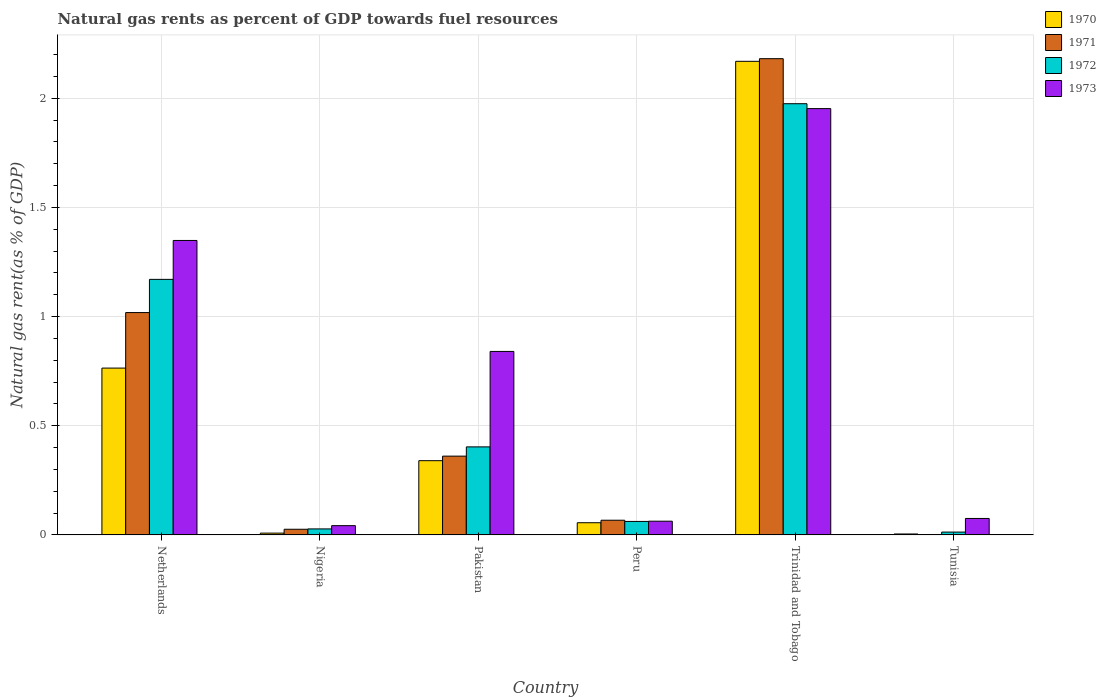How many different coloured bars are there?
Provide a short and direct response. 4. How many groups of bars are there?
Offer a very short reply. 6. What is the label of the 2nd group of bars from the left?
Offer a very short reply. Nigeria. What is the natural gas rent in 1970 in Nigeria?
Make the answer very short. 0.01. Across all countries, what is the maximum natural gas rent in 1972?
Your answer should be very brief. 1.98. Across all countries, what is the minimum natural gas rent in 1970?
Your answer should be compact. 0. In which country was the natural gas rent in 1972 maximum?
Keep it short and to the point. Trinidad and Tobago. In which country was the natural gas rent in 1972 minimum?
Ensure brevity in your answer.  Tunisia. What is the total natural gas rent in 1971 in the graph?
Your answer should be compact. 3.65. What is the difference between the natural gas rent in 1972 in Netherlands and that in Trinidad and Tobago?
Keep it short and to the point. -0.8. What is the difference between the natural gas rent in 1970 in Netherlands and the natural gas rent in 1972 in Tunisia?
Provide a short and direct response. 0.75. What is the average natural gas rent in 1972 per country?
Offer a terse response. 0.61. What is the difference between the natural gas rent of/in 1972 and natural gas rent of/in 1973 in Trinidad and Tobago?
Offer a terse response. 0.02. In how many countries, is the natural gas rent in 1970 greater than 1.6 %?
Give a very brief answer. 1. What is the ratio of the natural gas rent in 1971 in Pakistan to that in Trinidad and Tobago?
Your answer should be compact. 0.17. Is the natural gas rent in 1971 in Trinidad and Tobago less than that in Tunisia?
Provide a short and direct response. No. Is the difference between the natural gas rent in 1972 in Netherlands and Pakistan greater than the difference between the natural gas rent in 1973 in Netherlands and Pakistan?
Your answer should be compact. Yes. What is the difference between the highest and the second highest natural gas rent in 1970?
Provide a short and direct response. 0.42. What is the difference between the highest and the lowest natural gas rent in 1972?
Make the answer very short. 1.96. What does the 4th bar from the right in Trinidad and Tobago represents?
Ensure brevity in your answer.  1970. How many countries are there in the graph?
Ensure brevity in your answer.  6. Are the values on the major ticks of Y-axis written in scientific E-notation?
Make the answer very short. No. Where does the legend appear in the graph?
Ensure brevity in your answer.  Top right. How many legend labels are there?
Make the answer very short. 4. How are the legend labels stacked?
Ensure brevity in your answer.  Vertical. What is the title of the graph?
Keep it short and to the point. Natural gas rents as percent of GDP towards fuel resources. Does "2001" appear as one of the legend labels in the graph?
Give a very brief answer. No. What is the label or title of the Y-axis?
Provide a short and direct response. Natural gas rent(as % of GDP). What is the Natural gas rent(as % of GDP) of 1970 in Netherlands?
Give a very brief answer. 0.76. What is the Natural gas rent(as % of GDP) of 1971 in Netherlands?
Provide a short and direct response. 1.02. What is the Natural gas rent(as % of GDP) of 1972 in Netherlands?
Offer a terse response. 1.17. What is the Natural gas rent(as % of GDP) of 1973 in Netherlands?
Your answer should be compact. 1.35. What is the Natural gas rent(as % of GDP) in 1970 in Nigeria?
Your answer should be very brief. 0.01. What is the Natural gas rent(as % of GDP) of 1971 in Nigeria?
Provide a short and direct response. 0.03. What is the Natural gas rent(as % of GDP) of 1972 in Nigeria?
Your response must be concise. 0.03. What is the Natural gas rent(as % of GDP) in 1973 in Nigeria?
Keep it short and to the point. 0.04. What is the Natural gas rent(as % of GDP) of 1970 in Pakistan?
Your answer should be compact. 0.34. What is the Natural gas rent(as % of GDP) in 1971 in Pakistan?
Make the answer very short. 0.36. What is the Natural gas rent(as % of GDP) of 1972 in Pakistan?
Your answer should be compact. 0.4. What is the Natural gas rent(as % of GDP) of 1973 in Pakistan?
Ensure brevity in your answer.  0.84. What is the Natural gas rent(as % of GDP) in 1970 in Peru?
Your response must be concise. 0.06. What is the Natural gas rent(as % of GDP) in 1971 in Peru?
Give a very brief answer. 0.07. What is the Natural gas rent(as % of GDP) in 1972 in Peru?
Offer a very short reply. 0.06. What is the Natural gas rent(as % of GDP) in 1973 in Peru?
Your response must be concise. 0.06. What is the Natural gas rent(as % of GDP) of 1970 in Trinidad and Tobago?
Your answer should be compact. 2.17. What is the Natural gas rent(as % of GDP) in 1971 in Trinidad and Tobago?
Your response must be concise. 2.18. What is the Natural gas rent(as % of GDP) in 1972 in Trinidad and Tobago?
Provide a short and direct response. 1.98. What is the Natural gas rent(as % of GDP) in 1973 in Trinidad and Tobago?
Your answer should be compact. 1.95. What is the Natural gas rent(as % of GDP) in 1970 in Tunisia?
Keep it short and to the point. 0. What is the Natural gas rent(as % of GDP) in 1971 in Tunisia?
Your answer should be very brief. 0. What is the Natural gas rent(as % of GDP) of 1972 in Tunisia?
Your answer should be very brief. 0.01. What is the Natural gas rent(as % of GDP) of 1973 in Tunisia?
Provide a short and direct response. 0.08. Across all countries, what is the maximum Natural gas rent(as % of GDP) in 1970?
Give a very brief answer. 2.17. Across all countries, what is the maximum Natural gas rent(as % of GDP) in 1971?
Make the answer very short. 2.18. Across all countries, what is the maximum Natural gas rent(as % of GDP) of 1972?
Provide a short and direct response. 1.98. Across all countries, what is the maximum Natural gas rent(as % of GDP) of 1973?
Your answer should be very brief. 1.95. Across all countries, what is the minimum Natural gas rent(as % of GDP) of 1970?
Give a very brief answer. 0. Across all countries, what is the minimum Natural gas rent(as % of GDP) of 1971?
Offer a terse response. 0. Across all countries, what is the minimum Natural gas rent(as % of GDP) of 1972?
Make the answer very short. 0.01. Across all countries, what is the minimum Natural gas rent(as % of GDP) in 1973?
Give a very brief answer. 0.04. What is the total Natural gas rent(as % of GDP) of 1970 in the graph?
Offer a terse response. 3.34. What is the total Natural gas rent(as % of GDP) of 1971 in the graph?
Provide a succinct answer. 3.65. What is the total Natural gas rent(as % of GDP) in 1972 in the graph?
Keep it short and to the point. 3.65. What is the total Natural gas rent(as % of GDP) in 1973 in the graph?
Give a very brief answer. 4.32. What is the difference between the Natural gas rent(as % of GDP) of 1970 in Netherlands and that in Nigeria?
Make the answer very short. 0.76. What is the difference between the Natural gas rent(as % of GDP) of 1972 in Netherlands and that in Nigeria?
Provide a short and direct response. 1.14. What is the difference between the Natural gas rent(as % of GDP) of 1973 in Netherlands and that in Nigeria?
Give a very brief answer. 1.31. What is the difference between the Natural gas rent(as % of GDP) of 1970 in Netherlands and that in Pakistan?
Your response must be concise. 0.42. What is the difference between the Natural gas rent(as % of GDP) in 1971 in Netherlands and that in Pakistan?
Keep it short and to the point. 0.66. What is the difference between the Natural gas rent(as % of GDP) in 1972 in Netherlands and that in Pakistan?
Keep it short and to the point. 0.77. What is the difference between the Natural gas rent(as % of GDP) in 1973 in Netherlands and that in Pakistan?
Make the answer very short. 0.51. What is the difference between the Natural gas rent(as % of GDP) of 1970 in Netherlands and that in Peru?
Provide a short and direct response. 0.71. What is the difference between the Natural gas rent(as % of GDP) in 1971 in Netherlands and that in Peru?
Your answer should be compact. 0.95. What is the difference between the Natural gas rent(as % of GDP) of 1972 in Netherlands and that in Peru?
Your answer should be compact. 1.11. What is the difference between the Natural gas rent(as % of GDP) of 1973 in Netherlands and that in Peru?
Make the answer very short. 1.29. What is the difference between the Natural gas rent(as % of GDP) of 1970 in Netherlands and that in Trinidad and Tobago?
Your response must be concise. -1.41. What is the difference between the Natural gas rent(as % of GDP) in 1971 in Netherlands and that in Trinidad and Tobago?
Your answer should be very brief. -1.16. What is the difference between the Natural gas rent(as % of GDP) of 1972 in Netherlands and that in Trinidad and Tobago?
Offer a very short reply. -0.8. What is the difference between the Natural gas rent(as % of GDP) in 1973 in Netherlands and that in Trinidad and Tobago?
Give a very brief answer. -0.6. What is the difference between the Natural gas rent(as % of GDP) in 1970 in Netherlands and that in Tunisia?
Keep it short and to the point. 0.76. What is the difference between the Natural gas rent(as % of GDP) of 1971 in Netherlands and that in Tunisia?
Make the answer very short. 1.02. What is the difference between the Natural gas rent(as % of GDP) of 1972 in Netherlands and that in Tunisia?
Give a very brief answer. 1.16. What is the difference between the Natural gas rent(as % of GDP) in 1973 in Netherlands and that in Tunisia?
Give a very brief answer. 1.27. What is the difference between the Natural gas rent(as % of GDP) in 1970 in Nigeria and that in Pakistan?
Keep it short and to the point. -0.33. What is the difference between the Natural gas rent(as % of GDP) in 1971 in Nigeria and that in Pakistan?
Give a very brief answer. -0.34. What is the difference between the Natural gas rent(as % of GDP) of 1972 in Nigeria and that in Pakistan?
Keep it short and to the point. -0.38. What is the difference between the Natural gas rent(as % of GDP) in 1973 in Nigeria and that in Pakistan?
Provide a short and direct response. -0.8. What is the difference between the Natural gas rent(as % of GDP) in 1970 in Nigeria and that in Peru?
Make the answer very short. -0.05. What is the difference between the Natural gas rent(as % of GDP) in 1971 in Nigeria and that in Peru?
Offer a terse response. -0.04. What is the difference between the Natural gas rent(as % of GDP) in 1972 in Nigeria and that in Peru?
Make the answer very short. -0.03. What is the difference between the Natural gas rent(as % of GDP) of 1973 in Nigeria and that in Peru?
Give a very brief answer. -0.02. What is the difference between the Natural gas rent(as % of GDP) in 1970 in Nigeria and that in Trinidad and Tobago?
Provide a short and direct response. -2.16. What is the difference between the Natural gas rent(as % of GDP) of 1971 in Nigeria and that in Trinidad and Tobago?
Keep it short and to the point. -2.16. What is the difference between the Natural gas rent(as % of GDP) in 1972 in Nigeria and that in Trinidad and Tobago?
Offer a terse response. -1.95. What is the difference between the Natural gas rent(as % of GDP) in 1973 in Nigeria and that in Trinidad and Tobago?
Offer a terse response. -1.91. What is the difference between the Natural gas rent(as % of GDP) in 1970 in Nigeria and that in Tunisia?
Offer a terse response. 0. What is the difference between the Natural gas rent(as % of GDP) of 1971 in Nigeria and that in Tunisia?
Make the answer very short. 0.03. What is the difference between the Natural gas rent(as % of GDP) in 1972 in Nigeria and that in Tunisia?
Provide a succinct answer. 0.01. What is the difference between the Natural gas rent(as % of GDP) of 1973 in Nigeria and that in Tunisia?
Your answer should be compact. -0.03. What is the difference between the Natural gas rent(as % of GDP) in 1970 in Pakistan and that in Peru?
Your answer should be compact. 0.28. What is the difference between the Natural gas rent(as % of GDP) of 1971 in Pakistan and that in Peru?
Ensure brevity in your answer.  0.29. What is the difference between the Natural gas rent(as % of GDP) of 1972 in Pakistan and that in Peru?
Offer a terse response. 0.34. What is the difference between the Natural gas rent(as % of GDP) in 1973 in Pakistan and that in Peru?
Your answer should be very brief. 0.78. What is the difference between the Natural gas rent(as % of GDP) in 1970 in Pakistan and that in Trinidad and Tobago?
Your answer should be compact. -1.83. What is the difference between the Natural gas rent(as % of GDP) in 1971 in Pakistan and that in Trinidad and Tobago?
Your response must be concise. -1.82. What is the difference between the Natural gas rent(as % of GDP) of 1972 in Pakistan and that in Trinidad and Tobago?
Keep it short and to the point. -1.57. What is the difference between the Natural gas rent(as % of GDP) in 1973 in Pakistan and that in Trinidad and Tobago?
Your answer should be compact. -1.11. What is the difference between the Natural gas rent(as % of GDP) in 1970 in Pakistan and that in Tunisia?
Provide a short and direct response. 0.34. What is the difference between the Natural gas rent(as % of GDP) in 1971 in Pakistan and that in Tunisia?
Make the answer very short. 0.36. What is the difference between the Natural gas rent(as % of GDP) in 1972 in Pakistan and that in Tunisia?
Your answer should be compact. 0.39. What is the difference between the Natural gas rent(as % of GDP) in 1973 in Pakistan and that in Tunisia?
Provide a succinct answer. 0.77. What is the difference between the Natural gas rent(as % of GDP) of 1970 in Peru and that in Trinidad and Tobago?
Your answer should be compact. -2.11. What is the difference between the Natural gas rent(as % of GDP) of 1971 in Peru and that in Trinidad and Tobago?
Provide a short and direct response. -2.11. What is the difference between the Natural gas rent(as % of GDP) in 1972 in Peru and that in Trinidad and Tobago?
Your response must be concise. -1.91. What is the difference between the Natural gas rent(as % of GDP) of 1973 in Peru and that in Trinidad and Tobago?
Provide a short and direct response. -1.89. What is the difference between the Natural gas rent(as % of GDP) of 1970 in Peru and that in Tunisia?
Give a very brief answer. 0.05. What is the difference between the Natural gas rent(as % of GDP) of 1971 in Peru and that in Tunisia?
Keep it short and to the point. 0.07. What is the difference between the Natural gas rent(as % of GDP) of 1972 in Peru and that in Tunisia?
Provide a succinct answer. 0.05. What is the difference between the Natural gas rent(as % of GDP) of 1973 in Peru and that in Tunisia?
Give a very brief answer. -0.01. What is the difference between the Natural gas rent(as % of GDP) in 1970 in Trinidad and Tobago and that in Tunisia?
Offer a very short reply. 2.17. What is the difference between the Natural gas rent(as % of GDP) of 1971 in Trinidad and Tobago and that in Tunisia?
Offer a terse response. 2.18. What is the difference between the Natural gas rent(as % of GDP) in 1972 in Trinidad and Tobago and that in Tunisia?
Offer a very short reply. 1.96. What is the difference between the Natural gas rent(as % of GDP) of 1973 in Trinidad and Tobago and that in Tunisia?
Make the answer very short. 1.88. What is the difference between the Natural gas rent(as % of GDP) of 1970 in Netherlands and the Natural gas rent(as % of GDP) of 1971 in Nigeria?
Provide a short and direct response. 0.74. What is the difference between the Natural gas rent(as % of GDP) of 1970 in Netherlands and the Natural gas rent(as % of GDP) of 1972 in Nigeria?
Keep it short and to the point. 0.74. What is the difference between the Natural gas rent(as % of GDP) in 1970 in Netherlands and the Natural gas rent(as % of GDP) in 1973 in Nigeria?
Offer a very short reply. 0.72. What is the difference between the Natural gas rent(as % of GDP) of 1971 in Netherlands and the Natural gas rent(as % of GDP) of 1972 in Nigeria?
Give a very brief answer. 0.99. What is the difference between the Natural gas rent(as % of GDP) of 1971 in Netherlands and the Natural gas rent(as % of GDP) of 1973 in Nigeria?
Make the answer very short. 0.98. What is the difference between the Natural gas rent(as % of GDP) of 1972 in Netherlands and the Natural gas rent(as % of GDP) of 1973 in Nigeria?
Your answer should be compact. 1.13. What is the difference between the Natural gas rent(as % of GDP) in 1970 in Netherlands and the Natural gas rent(as % of GDP) in 1971 in Pakistan?
Offer a very short reply. 0.4. What is the difference between the Natural gas rent(as % of GDP) in 1970 in Netherlands and the Natural gas rent(as % of GDP) in 1972 in Pakistan?
Provide a short and direct response. 0.36. What is the difference between the Natural gas rent(as % of GDP) in 1970 in Netherlands and the Natural gas rent(as % of GDP) in 1973 in Pakistan?
Your response must be concise. -0.08. What is the difference between the Natural gas rent(as % of GDP) in 1971 in Netherlands and the Natural gas rent(as % of GDP) in 1972 in Pakistan?
Keep it short and to the point. 0.62. What is the difference between the Natural gas rent(as % of GDP) in 1971 in Netherlands and the Natural gas rent(as % of GDP) in 1973 in Pakistan?
Offer a very short reply. 0.18. What is the difference between the Natural gas rent(as % of GDP) in 1972 in Netherlands and the Natural gas rent(as % of GDP) in 1973 in Pakistan?
Give a very brief answer. 0.33. What is the difference between the Natural gas rent(as % of GDP) of 1970 in Netherlands and the Natural gas rent(as % of GDP) of 1971 in Peru?
Ensure brevity in your answer.  0.7. What is the difference between the Natural gas rent(as % of GDP) in 1970 in Netherlands and the Natural gas rent(as % of GDP) in 1972 in Peru?
Provide a succinct answer. 0.7. What is the difference between the Natural gas rent(as % of GDP) in 1970 in Netherlands and the Natural gas rent(as % of GDP) in 1973 in Peru?
Make the answer very short. 0.7. What is the difference between the Natural gas rent(as % of GDP) of 1971 in Netherlands and the Natural gas rent(as % of GDP) of 1972 in Peru?
Offer a very short reply. 0.96. What is the difference between the Natural gas rent(as % of GDP) in 1971 in Netherlands and the Natural gas rent(as % of GDP) in 1973 in Peru?
Your response must be concise. 0.96. What is the difference between the Natural gas rent(as % of GDP) in 1972 in Netherlands and the Natural gas rent(as % of GDP) in 1973 in Peru?
Offer a very short reply. 1.11. What is the difference between the Natural gas rent(as % of GDP) in 1970 in Netherlands and the Natural gas rent(as % of GDP) in 1971 in Trinidad and Tobago?
Offer a very short reply. -1.42. What is the difference between the Natural gas rent(as % of GDP) in 1970 in Netherlands and the Natural gas rent(as % of GDP) in 1972 in Trinidad and Tobago?
Keep it short and to the point. -1.21. What is the difference between the Natural gas rent(as % of GDP) in 1970 in Netherlands and the Natural gas rent(as % of GDP) in 1973 in Trinidad and Tobago?
Provide a short and direct response. -1.19. What is the difference between the Natural gas rent(as % of GDP) in 1971 in Netherlands and the Natural gas rent(as % of GDP) in 1972 in Trinidad and Tobago?
Give a very brief answer. -0.96. What is the difference between the Natural gas rent(as % of GDP) in 1971 in Netherlands and the Natural gas rent(as % of GDP) in 1973 in Trinidad and Tobago?
Offer a very short reply. -0.93. What is the difference between the Natural gas rent(as % of GDP) of 1972 in Netherlands and the Natural gas rent(as % of GDP) of 1973 in Trinidad and Tobago?
Your response must be concise. -0.78. What is the difference between the Natural gas rent(as % of GDP) of 1970 in Netherlands and the Natural gas rent(as % of GDP) of 1971 in Tunisia?
Give a very brief answer. 0.76. What is the difference between the Natural gas rent(as % of GDP) of 1970 in Netherlands and the Natural gas rent(as % of GDP) of 1972 in Tunisia?
Provide a short and direct response. 0.75. What is the difference between the Natural gas rent(as % of GDP) of 1970 in Netherlands and the Natural gas rent(as % of GDP) of 1973 in Tunisia?
Your response must be concise. 0.69. What is the difference between the Natural gas rent(as % of GDP) in 1971 in Netherlands and the Natural gas rent(as % of GDP) in 1972 in Tunisia?
Offer a terse response. 1.01. What is the difference between the Natural gas rent(as % of GDP) of 1971 in Netherlands and the Natural gas rent(as % of GDP) of 1973 in Tunisia?
Provide a succinct answer. 0.94. What is the difference between the Natural gas rent(as % of GDP) of 1972 in Netherlands and the Natural gas rent(as % of GDP) of 1973 in Tunisia?
Ensure brevity in your answer.  1.1. What is the difference between the Natural gas rent(as % of GDP) in 1970 in Nigeria and the Natural gas rent(as % of GDP) in 1971 in Pakistan?
Offer a very short reply. -0.35. What is the difference between the Natural gas rent(as % of GDP) of 1970 in Nigeria and the Natural gas rent(as % of GDP) of 1972 in Pakistan?
Offer a terse response. -0.4. What is the difference between the Natural gas rent(as % of GDP) of 1970 in Nigeria and the Natural gas rent(as % of GDP) of 1973 in Pakistan?
Your response must be concise. -0.83. What is the difference between the Natural gas rent(as % of GDP) of 1971 in Nigeria and the Natural gas rent(as % of GDP) of 1972 in Pakistan?
Make the answer very short. -0.38. What is the difference between the Natural gas rent(as % of GDP) of 1971 in Nigeria and the Natural gas rent(as % of GDP) of 1973 in Pakistan?
Your response must be concise. -0.81. What is the difference between the Natural gas rent(as % of GDP) in 1972 in Nigeria and the Natural gas rent(as % of GDP) in 1973 in Pakistan?
Offer a terse response. -0.81. What is the difference between the Natural gas rent(as % of GDP) of 1970 in Nigeria and the Natural gas rent(as % of GDP) of 1971 in Peru?
Keep it short and to the point. -0.06. What is the difference between the Natural gas rent(as % of GDP) of 1970 in Nigeria and the Natural gas rent(as % of GDP) of 1972 in Peru?
Offer a very short reply. -0.05. What is the difference between the Natural gas rent(as % of GDP) of 1970 in Nigeria and the Natural gas rent(as % of GDP) of 1973 in Peru?
Make the answer very short. -0.05. What is the difference between the Natural gas rent(as % of GDP) of 1971 in Nigeria and the Natural gas rent(as % of GDP) of 1972 in Peru?
Offer a very short reply. -0.04. What is the difference between the Natural gas rent(as % of GDP) of 1971 in Nigeria and the Natural gas rent(as % of GDP) of 1973 in Peru?
Your answer should be compact. -0.04. What is the difference between the Natural gas rent(as % of GDP) of 1972 in Nigeria and the Natural gas rent(as % of GDP) of 1973 in Peru?
Give a very brief answer. -0.04. What is the difference between the Natural gas rent(as % of GDP) of 1970 in Nigeria and the Natural gas rent(as % of GDP) of 1971 in Trinidad and Tobago?
Keep it short and to the point. -2.17. What is the difference between the Natural gas rent(as % of GDP) in 1970 in Nigeria and the Natural gas rent(as % of GDP) in 1972 in Trinidad and Tobago?
Ensure brevity in your answer.  -1.97. What is the difference between the Natural gas rent(as % of GDP) of 1970 in Nigeria and the Natural gas rent(as % of GDP) of 1973 in Trinidad and Tobago?
Your answer should be very brief. -1.94. What is the difference between the Natural gas rent(as % of GDP) of 1971 in Nigeria and the Natural gas rent(as % of GDP) of 1972 in Trinidad and Tobago?
Keep it short and to the point. -1.95. What is the difference between the Natural gas rent(as % of GDP) in 1971 in Nigeria and the Natural gas rent(as % of GDP) in 1973 in Trinidad and Tobago?
Provide a succinct answer. -1.93. What is the difference between the Natural gas rent(as % of GDP) of 1972 in Nigeria and the Natural gas rent(as % of GDP) of 1973 in Trinidad and Tobago?
Provide a succinct answer. -1.93. What is the difference between the Natural gas rent(as % of GDP) of 1970 in Nigeria and the Natural gas rent(as % of GDP) of 1971 in Tunisia?
Keep it short and to the point. 0.01. What is the difference between the Natural gas rent(as % of GDP) of 1970 in Nigeria and the Natural gas rent(as % of GDP) of 1972 in Tunisia?
Make the answer very short. -0. What is the difference between the Natural gas rent(as % of GDP) of 1970 in Nigeria and the Natural gas rent(as % of GDP) of 1973 in Tunisia?
Give a very brief answer. -0.07. What is the difference between the Natural gas rent(as % of GDP) of 1971 in Nigeria and the Natural gas rent(as % of GDP) of 1972 in Tunisia?
Offer a terse response. 0.01. What is the difference between the Natural gas rent(as % of GDP) of 1971 in Nigeria and the Natural gas rent(as % of GDP) of 1973 in Tunisia?
Provide a succinct answer. -0.05. What is the difference between the Natural gas rent(as % of GDP) in 1972 in Nigeria and the Natural gas rent(as % of GDP) in 1973 in Tunisia?
Your answer should be very brief. -0.05. What is the difference between the Natural gas rent(as % of GDP) in 1970 in Pakistan and the Natural gas rent(as % of GDP) in 1971 in Peru?
Offer a terse response. 0.27. What is the difference between the Natural gas rent(as % of GDP) in 1970 in Pakistan and the Natural gas rent(as % of GDP) in 1972 in Peru?
Offer a terse response. 0.28. What is the difference between the Natural gas rent(as % of GDP) in 1970 in Pakistan and the Natural gas rent(as % of GDP) in 1973 in Peru?
Offer a very short reply. 0.28. What is the difference between the Natural gas rent(as % of GDP) of 1971 in Pakistan and the Natural gas rent(as % of GDP) of 1972 in Peru?
Give a very brief answer. 0.3. What is the difference between the Natural gas rent(as % of GDP) of 1971 in Pakistan and the Natural gas rent(as % of GDP) of 1973 in Peru?
Provide a short and direct response. 0.3. What is the difference between the Natural gas rent(as % of GDP) in 1972 in Pakistan and the Natural gas rent(as % of GDP) in 1973 in Peru?
Offer a very short reply. 0.34. What is the difference between the Natural gas rent(as % of GDP) in 1970 in Pakistan and the Natural gas rent(as % of GDP) in 1971 in Trinidad and Tobago?
Give a very brief answer. -1.84. What is the difference between the Natural gas rent(as % of GDP) of 1970 in Pakistan and the Natural gas rent(as % of GDP) of 1972 in Trinidad and Tobago?
Your answer should be compact. -1.64. What is the difference between the Natural gas rent(as % of GDP) of 1970 in Pakistan and the Natural gas rent(as % of GDP) of 1973 in Trinidad and Tobago?
Offer a terse response. -1.61. What is the difference between the Natural gas rent(as % of GDP) of 1971 in Pakistan and the Natural gas rent(as % of GDP) of 1972 in Trinidad and Tobago?
Make the answer very short. -1.61. What is the difference between the Natural gas rent(as % of GDP) of 1971 in Pakistan and the Natural gas rent(as % of GDP) of 1973 in Trinidad and Tobago?
Make the answer very short. -1.59. What is the difference between the Natural gas rent(as % of GDP) of 1972 in Pakistan and the Natural gas rent(as % of GDP) of 1973 in Trinidad and Tobago?
Give a very brief answer. -1.55. What is the difference between the Natural gas rent(as % of GDP) in 1970 in Pakistan and the Natural gas rent(as % of GDP) in 1971 in Tunisia?
Provide a succinct answer. 0.34. What is the difference between the Natural gas rent(as % of GDP) in 1970 in Pakistan and the Natural gas rent(as % of GDP) in 1972 in Tunisia?
Give a very brief answer. 0.33. What is the difference between the Natural gas rent(as % of GDP) of 1970 in Pakistan and the Natural gas rent(as % of GDP) of 1973 in Tunisia?
Your answer should be compact. 0.26. What is the difference between the Natural gas rent(as % of GDP) in 1971 in Pakistan and the Natural gas rent(as % of GDP) in 1972 in Tunisia?
Your answer should be very brief. 0.35. What is the difference between the Natural gas rent(as % of GDP) in 1971 in Pakistan and the Natural gas rent(as % of GDP) in 1973 in Tunisia?
Provide a succinct answer. 0.29. What is the difference between the Natural gas rent(as % of GDP) in 1972 in Pakistan and the Natural gas rent(as % of GDP) in 1973 in Tunisia?
Offer a terse response. 0.33. What is the difference between the Natural gas rent(as % of GDP) in 1970 in Peru and the Natural gas rent(as % of GDP) in 1971 in Trinidad and Tobago?
Keep it short and to the point. -2.13. What is the difference between the Natural gas rent(as % of GDP) of 1970 in Peru and the Natural gas rent(as % of GDP) of 1972 in Trinidad and Tobago?
Your response must be concise. -1.92. What is the difference between the Natural gas rent(as % of GDP) of 1970 in Peru and the Natural gas rent(as % of GDP) of 1973 in Trinidad and Tobago?
Your answer should be very brief. -1.9. What is the difference between the Natural gas rent(as % of GDP) of 1971 in Peru and the Natural gas rent(as % of GDP) of 1972 in Trinidad and Tobago?
Ensure brevity in your answer.  -1.91. What is the difference between the Natural gas rent(as % of GDP) in 1971 in Peru and the Natural gas rent(as % of GDP) in 1973 in Trinidad and Tobago?
Your response must be concise. -1.89. What is the difference between the Natural gas rent(as % of GDP) in 1972 in Peru and the Natural gas rent(as % of GDP) in 1973 in Trinidad and Tobago?
Offer a terse response. -1.89. What is the difference between the Natural gas rent(as % of GDP) of 1970 in Peru and the Natural gas rent(as % of GDP) of 1971 in Tunisia?
Give a very brief answer. 0.06. What is the difference between the Natural gas rent(as % of GDP) in 1970 in Peru and the Natural gas rent(as % of GDP) in 1972 in Tunisia?
Your answer should be compact. 0.04. What is the difference between the Natural gas rent(as % of GDP) in 1970 in Peru and the Natural gas rent(as % of GDP) in 1973 in Tunisia?
Provide a short and direct response. -0.02. What is the difference between the Natural gas rent(as % of GDP) in 1971 in Peru and the Natural gas rent(as % of GDP) in 1972 in Tunisia?
Ensure brevity in your answer.  0.05. What is the difference between the Natural gas rent(as % of GDP) in 1971 in Peru and the Natural gas rent(as % of GDP) in 1973 in Tunisia?
Your response must be concise. -0.01. What is the difference between the Natural gas rent(as % of GDP) in 1972 in Peru and the Natural gas rent(as % of GDP) in 1973 in Tunisia?
Your answer should be very brief. -0.01. What is the difference between the Natural gas rent(as % of GDP) of 1970 in Trinidad and Tobago and the Natural gas rent(as % of GDP) of 1971 in Tunisia?
Keep it short and to the point. 2.17. What is the difference between the Natural gas rent(as % of GDP) in 1970 in Trinidad and Tobago and the Natural gas rent(as % of GDP) in 1972 in Tunisia?
Your answer should be very brief. 2.16. What is the difference between the Natural gas rent(as % of GDP) of 1970 in Trinidad and Tobago and the Natural gas rent(as % of GDP) of 1973 in Tunisia?
Offer a very short reply. 2.09. What is the difference between the Natural gas rent(as % of GDP) in 1971 in Trinidad and Tobago and the Natural gas rent(as % of GDP) in 1972 in Tunisia?
Ensure brevity in your answer.  2.17. What is the difference between the Natural gas rent(as % of GDP) of 1971 in Trinidad and Tobago and the Natural gas rent(as % of GDP) of 1973 in Tunisia?
Make the answer very short. 2.11. What is the difference between the Natural gas rent(as % of GDP) in 1972 in Trinidad and Tobago and the Natural gas rent(as % of GDP) in 1973 in Tunisia?
Your answer should be compact. 1.9. What is the average Natural gas rent(as % of GDP) of 1970 per country?
Your answer should be very brief. 0.56. What is the average Natural gas rent(as % of GDP) in 1971 per country?
Make the answer very short. 0.61. What is the average Natural gas rent(as % of GDP) in 1972 per country?
Offer a terse response. 0.61. What is the average Natural gas rent(as % of GDP) in 1973 per country?
Ensure brevity in your answer.  0.72. What is the difference between the Natural gas rent(as % of GDP) in 1970 and Natural gas rent(as % of GDP) in 1971 in Netherlands?
Make the answer very short. -0.25. What is the difference between the Natural gas rent(as % of GDP) of 1970 and Natural gas rent(as % of GDP) of 1972 in Netherlands?
Make the answer very short. -0.41. What is the difference between the Natural gas rent(as % of GDP) of 1970 and Natural gas rent(as % of GDP) of 1973 in Netherlands?
Keep it short and to the point. -0.58. What is the difference between the Natural gas rent(as % of GDP) in 1971 and Natural gas rent(as % of GDP) in 1972 in Netherlands?
Ensure brevity in your answer.  -0.15. What is the difference between the Natural gas rent(as % of GDP) of 1971 and Natural gas rent(as % of GDP) of 1973 in Netherlands?
Your answer should be compact. -0.33. What is the difference between the Natural gas rent(as % of GDP) in 1972 and Natural gas rent(as % of GDP) in 1973 in Netherlands?
Offer a terse response. -0.18. What is the difference between the Natural gas rent(as % of GDP) of 1970 and Natural gas rent(as % of GDP) of 1971 in Nigeria?
Offer a terse response. -0.02. What is the difference between the Natural gas rent(as % of GDP) of 1970 and Natural gas rent(as % of GDP) of 1972 in Nigeria?
Make the answer very short. -0.02. What is the difference between the Natural gas rent(as % of GDP) in 1970 and Natural gas rent(as % of GDP) in 1973 in Nigeria?
Provide a succinct answer. -0.03. What is the difference between the Natural gas rent(as % of GDP) in 1971 and Natural gas rent(as % of GDP) in 1972 in Nigeria?
Your answer should be very brief. -0. What is the difference between the Natural gas rent(as % of GDP) in 1971 and Natural gas rent(as % of GDP) in 1973 in Nigeria?
Offer a very short reply. -0.02. What is the difference between the Natural gas rent(as % of GDP) in 1972 and Natural gas rent(as % of GDP) in 1973 in Nigeria?
Ensure brevity in your answer.  -0.01. What is the difference between the Natural gas rent(as % of GDP) in 1970 and Natural gas rent(as % of GDP) in 1971 in Pakistan?
Your answer should be very brief. -0.02. What is the difference between the Natural gas rent(as % of GDP) of 1970 and Natural gas rent(as % of GDP) of 1972 in Pakistan?
Your response must be concise. -0.06. What is the difference between the Natural gas rent(as % of GDP) of 1970 and Natural gas rent(as % of GDP) of 1973 in Pakistan?
Give a very brief answer. -0.5. What is the difference between the Natural gas rent(as % of GDP) in 1971 and Natural gas rent(as % of GDP) in 1972 in Pakistan?
Your answer should be very brief. -0.04. What is the difference between the Natural gas rent(as % of GDP) of 1971 and Natural gas rent(as % of GDP) of 1973 in Pakistan?
Give a very brief answer. -0.48. What is the difference between the Natural gas rent(as % of GDP) of 1972 and Natural gas rent(as % of GDP) of 1973 in Pakistan?
Provide a short and direct response. -0.44. What is the difference between the Natural gas rent(as % of GDP) in 1970 and Natural gas rent(as % of GDP) in 1971 in Peru?
Your answer should be very brief. -0.01. What is the difference between the Natural gas rent(as % of GDP) in 1970 and Natural gas rent(as % of GDP) in 1972 in Peru?
Offer a very short reply. -0.01. What is the difference between the Natural gas rent(as % of GDP) in 1970 and Natural gas rent(as % of GDP) in 1973 in Peru?
Your answer should be compact. -0.01. What is the difference between the Natural gas rent(as % of GDP) of 1971 and Natural gas rent(as % of GDP) of 1972 in Peru?
Your answer should be compact. 0.01. What is the difference between the Natural gas rent(as % of GDP) in 1971 and Natural gas rent(as % of GDP) in 1973 in Peru?
Provide a short and direct response. 0. What is the difference between the Natural gas rent(as % of GDP) in 1972 and Natural gas rent(as % of GDP) in 1973 in Peru?
Ensure brevity in your answer.  -0. What is the difference between the Natural gas rent(as % of GDP) of 1970 and Natural gas rent(as % of GDP) of 1971 in Trinidad and Tobago?
Offer a terse response. -0.01. What is the difference between the Natural gas rent(as % of GDP) in 1970 and Natural gas rent(as % of GDP) in 1972 in Trinidad and Tobago?
Your response must be concise. 0.19. What is the difference between the Natural gas rent(as % of GDP) in 1970 and Natural gas rent(as % of GDP) in 1973 in Trinidad and Tobago?
Offer a very short reply. 0.22. What is the difference between the Natural gas rent(as % of GDP) of 1971 and Natural gas rent(as % of GDP) of 1972 in Trinidad and Tobago?
Your answer should be compact. 0.21. What is the difference between the Natural gas rent(as % of GDP) of 1971 and Natural gas rent(as % of GDP) of 1973 in Trinidad and Tobago?
Your response must be concise. 0.23. What is the difference between the Natural gas rent(as % of GDP) of 1972 and Natural gas rent(as % of GDP) of 1973 in Trinidad and Tobago?
Provide a succinct answer. 0.02. What is the difference between the Natural gas rent(as % of GDP) in 1970 and Natural gas rent(as % of GDP) in 1971 in Tunisia?
Make the answer very short. 0. What is the difference between the Natural gas rent(as % of GDP) in 1970 and Natural gas rent(as % of GDP) in 1972 in Tunisia?
Your answer should be compact. -0.01. What is the difference between the Natural gas rent(as % of GDP) of 1970 and Natural gas rent(as % of GDP) of 1973 in Tunisia?
Provide a succinct answer. -0.07. What is the difference between the Natural gas rent(as % of GDP) in 1971 and Natural gas rent(as % of GDP) in 1972 in Tunisia?
Offer a terse response. -0.01. What is the difference between the Natural gas rent(as % of GDP) in 1971 and Natural gas rent(as % of GDP) in 1973 in Tunisia?
Your response must be concise. -0.07. What is the difference between the Natural gas rent(as % of GDP) in 1972 and Natural gas rent(as % of GDP) in 1973 in Tunisia?
Provide a succinct answer. -0.06. What is the ratio of the Natural gas rent(as % of GDP) of 1970 in Netherlands to that in Nigeria?
Offer a terse response. 93.94. What is the ratio of the Natural gas rent(as % of GDP) in 1971 in Netherlands to that in Nigeria?
Keep it short and to the point. 39.48. What is the ratio of the Natural gas rent(as % of GDP) in 1972 in Netherlands to that in Nigeria?
Make the answer very short. 42.7. What is the ratio of the Natural gas rent(as % of GDP) in 1973 in Netherlands to that in Nigeria?
Provide a short and direct response. 31.84. What is the ratio of the Natural gas rent(as % of GDP) in 1970 in Netherlands to that in Pakistan?
Make the answer very short. 2.25. What is the ratio of the Natural gas rent(as % of GDP) of 1971 in Netherlands to that in Pakistan?
Make the answer very short. 2.82. What is the ratio of the Natural gas rent(as % of GDP) in 1972 in Netherlands to that in Pakistan?
Ensure brevity in your answer.  2.9. What is the ratio of the Natural gas rent(as % of GDP) in 1973 in Netherlands to that in Pakistan?
Make the answer very short. 1.6. What is the ratio of the Natural gas rent(as % of GDP) of 1970 in Netherlands to that in Peru?
Your answer should be very brief. 13.7. What is the ratio of the Natural gas rent(as % of GDP) of 1971 in Netherlands to that in Peru?
Provide a succinct answer. 15.16. What is the ratio of the Natural gas rent(as % of GDP) in 1972 in Netherlands to that in Peru?
Give a very brief answer. 18.98. What is the ratio of the Natural gas rent(as % of GDP) in 1973 in Netherlands to that in Peru?
Provide a succinct answer. 21.49. What is the ratio of the Natural gas rent(as % of GDP) of 1970 in Netherlands to that in Trinidad and Tobago?
Provide a short and direct response. 0.35. What is the ratio of the Natural gas rent(as % of GDP) in 1971 in Netherlands to that in Trinidad and Tobago?
Provide a short and direct response. 0.47. What is the ratio of the Natural gas rent(as % of GDP) in 1972 in Netherlands to that in Trinidad and Tobago?
Offer a very short reply. 0.59. What is the ratio of the Natural gas rent(as % of GDP) in 1973 in Netherlands to that in Trinidad and Tobago?
Give a very brief answer. 0.69. What is the ratio of the Natural gas rent(as % of GDP) of 1970 in Netherlands to that in Tunisia?
Your answer should be compact. 180.16. What is the ratio of the Natural gas rent(as % of GDP) of 1971 in Netherlands to that in Tunisia?
Your answer should be very brief. 1372.84. What is the ratio of the Natural gas rent(as % of GDP) in 1972 in Netherlands to that in Tunisia?
Provide a succinct answer. 90.9. What is the ratio of the Natural gas rent(as % of GDP) in 1973 in Netherlands to that in Tunisia?
Offer a terse response. 17.92. What is the ratio of the Natural gas rent(as % of GDP) of 1970 in Nigeria to that in Pakistan?
Your answer should be very brief. 0.02. What is the ratio of the Natural gas rent(as % of GDP) of 1971 in Nigeria to that in Pakistan?
Provide a succinct answer. 0.07. What is the ratio of the Natural gas rent(as % of GDP) in 1972 in Nigeria to that in Pakistan?
Keep it short and to the point. 0.07. What is the ratio of the Natural gas rent(as % of GDP) of 1973 in Nigeria to that in Pakistan?
Your answer should be compact. 0.05. What is the ratio of the Natural gas rent(as % of GDP) in 1970 in Nigeria to that in Peru?
Your response must be concise. 0.15. What is the ratio of the Natural gas rent(as % of GDP) in 1971 in Nigeria to that in Peru?
Offer a very short reply. 0.38. What is the ratio of the Natural gas rent(as % of GDP) in 1972 in Nigeria to that in Peru?
Your answer should be very brief. 0.44. What is the ratio of the Natural gas rent(as % of GDP) of 1973 in Nigeria to that in Peru?
Offer a very short reply. 0.67. What is the ratio of the Natural gas rent(as % of GDP) in 1970 in Nigeria to that in Trinidad and Tobago?
Your response must be concise. 0. What is the ratio of the Natural gas rent(as % of GDP) in 1971 in Nigeria to that in Trinidad and Tobago?
Your answer should be compact. 0.01. What is the ratio of the Natural gas rent(as % of GDP) of 1972 in Nigeria to that in Trinidad and Tobago?
Keep it short and to the point. 0.01. What is the ratio of the Natural gas rent(as % of GDP) in 1973 in Nigeria to that in Trinidad and Tobago?
Your answer should be very brief. 0.02. What is the ratio of the Natural gas rent(as % of GDP) of 1970 in Nigeria to that in Tunisia?
Make the answer very short. 1.92. What is the ratio of the Natural gas rent(as % of GDP) in 1971 in Nigeria to that in Tunisia?
Keep it short and to the point. 34.77. What is the ratio of the Natural gas rent(as % of GDP) of 1972 in Nigeria to that in Tunisia?
Your answer should be very brief. 2.13. What is the ratio of the Natural gas rent(as % of GDP) in 1973 in Nigeria to that in Tunisia?
Provide a succinct answer. 0.56. What is the ratio of the Natural gas rent(as % of GDP) of 1970 in Pakistan to that in Peru?
Keep it short and to the point. 6.1. What is the ratio of the Natural gas rent(as % of GDP) of 1971 in Pakistan to that in Peru?
Make the answer very short. 5.37. What is the ratio of the Natural gas rent(as % of GDP) of 1972 in Pakistan to that in Peru?
Offer a terse response. 6.54. What is the ratio of the Natural gas rent(as % of GDP) in 1973 in Pakistan to that in Peru?
Offer a very short reply. 13.39. What is the ratio of the Natural gas rent(as % of GDP) of 1970 in Pakistan to that in Trinidad and Tobago?
Ensure brevity in your answer.  0.16. What is the ratio of the Natural gas rent(as % of GDP) in 1971 in Pakistan to that in Trinidad and Tobago?
Your answer should be compact. 0.17. What is the ratio of the Natural gas rent(as % of GDP) in 1972 in Pakistan to that in Trinidad and Tobago?
Your response must be concise. 0.2. What is the ratio of the Natural gas rent(as % of GDP) of 1973 in Pakistan to that in Trinidad and Tobago?
Give a very brief answer. 0.43. What is the ratio of the Natural gas rent(as % of GDP) in 1970 in Pakistan to that in Tunisia?
Keep it short and to the point. 80.16. What is the ratio of the Natural gas rent(as % of GDP) in 1971 in Pakistan to that in Tunisia?
Keep it short and to the point. 486.4. What is the ratio of the Natural gas rent(as % of GDP) in 1972 in Pakistan to that in Tunisia?
Provide a succinct answer. 31.31. What is the ratio of the Natural gas rent(as % of GDP) of 1973 in Pakistan to that in Tunisia?
Your answer should be very brief. 11.17. What is the ratio of the Natural gas rent(as % of GDP) of 1970 in Peru to that in Trinidad and Tobago?
Provide a short and direct response. 0.03. What is the ratio of the Natural gas rent(as % of GDP) in 1971 in Peru to that in Trinidad and Tobago?
Provide a short and direct response. 0.03. What is the ratio of the Natural gas rent(as % of GDP) of 1972 in Peru to that in Trinidad and Tobago?
Provide a succinct answer. 0.03. What is the ratio of the Natural gas rent(as % of GDP) in 1973 in Peru to that in Trinidad and Tobago?
Provide a short and direct response. 0.03. What is the ratio of the Natural gas rent(as % of GDP) of 1970 in Peru to that in Tunisia?
Offer a terse response. 13.15. What is the ratio of the Natural gas rent(as % of GDP) of 1971 in Peru to that in Tunisia?
Provide a succinct answer. 90.55. What is the ratio of the Natural gas rent(as % of GDP) in 1972 in Peru to that in Tunisia?
Your response must be concise. 4.79. What is the ratio of the Natural gas rent(as % of GDP) of 1973 in Peru to that in Tunisia?
Give a very brief answer. 0.83. What is the ratio of the Natural gas rent(as % of GDP) in 1970 in Trinidad and Tobago to that in Tunisia?
Provide a short and direct response. 511.49. What is the ratio of the Natural gas rent(as % of GDP) of 1971 in Trinidad and Tobago to that in Tunisia?
Make the answer very short. 2940.6. What is the ratio of the Natural gas rent(as % of GDP) of 1972 in Trinidad and Tobago to that in Tunisia?
Your answer should be compact. 153.39. What is the ratio of the Natural gas rent(as % of GDP) in 1973 in Trinidad and Tobago to that in Tunisia?
Your answer should be compact. 25.94. What is the difference between the highest and the second highest Natural gas rent(as % of GDP) in 1970?
Ensure brevity in your answer.  1.41. What is the difference between the highest and the second highest Natural gas rent(as % of GDP) in 1971?
Your answer should be very brief. 1.16. What is the difference between the highest and the second highest Natural gas rent(as % of GDP) of 1972?
Ensure brevity in your answer.  0.8. What is the difference between the highest and the second highest Natural gas rent(as % of GDP) in 1973?
Provide a succinct answer. 0.6. What is the difference between the highest and the lowest Natural gas rent(as % of GDP) in 1970?
Give a very brief answer. 2.17. What is the difference between the highest and the lowest Natural gas rent(as % of GDP) in 1971?
Ensure brevity in your answer.  2.18. What is the difference between the highest and the lowest Natural gas rent(as % of GDP) of 1972?
Your response must be concise. 1.96. What is the difference between the highest and the lowest Natural gas rent(as % of GDP) of 1973?
Your answer should be very brief. 1.91. 